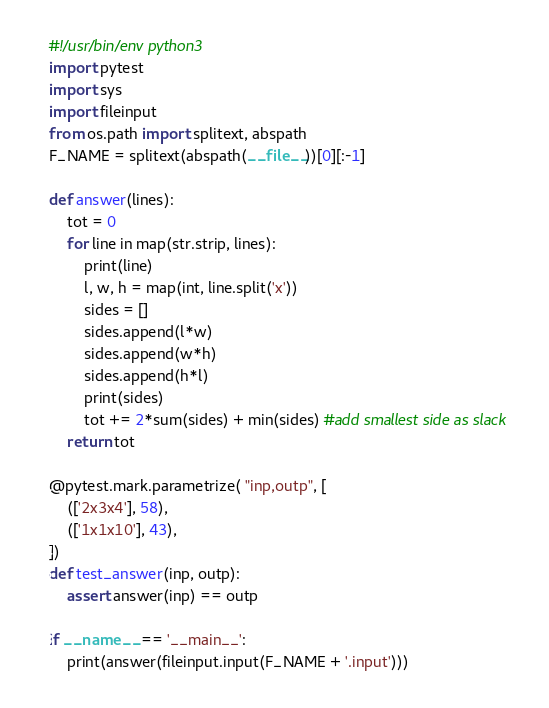Convert code to text. <code><loc_0><loc_0><loc_500><loc_500><_Python_>#!/usr/bin/env python3
import pytest
import sys
import fileinput
from os.path import splitext, abspath
F_NAME = splitext(abspath(__file__))[0][:-1]

def answer(lines):
    tot = 0
    for line in map(str.strip, lines):
        print(line)
        l, w, h = map(int, line.split('x'))
        sides = []
        sides.append(l*w)
        sides.append(w*h)
        sides.append(h*l)
        print(sides)
        tot += 2*sum(sides) + min(sides) #add smallest side as slack
    return tot

@pytest.mark.parametrize( "inp,outp", [
    (['2x3x4'], 58),
    (['1x1x10'], 43),
])
def test_answer(inp, outp):
    assert answer(inp) == outp

if __name__ == '__main__':
    print(answer(fileinput.input(F_NAME + '.input')))

</code> 